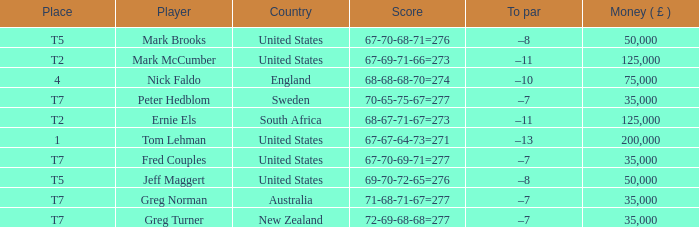What is Score, when Country is "United States", and when Player is "Mark Brooks"? 67-70-68-71=276. Would you mind parsing the complete table? {'header': ['Place', 'Player', 'Country', 'Score', 'To par', 'Money ( £ )'], 'rows': [['T5', 'Mark Brooks', 'United States', '67-70-68-71=276', '–8', '50,000'], ['T2', 'Mark McCumber', 'United States', '67-69-71-66=273', '–11', '125,000'], ['4', 'Nick Faldo', 'England', '68-68-68-70=274', '–10', '75,000'], ['T7', 'Peter Hedblom', 'Sweden', '70-65-75-67=277', '–7', '35,000'], ['T2', 'Ernie Els', 'South Africa', '68-67-71-67=273', '–11', '125,000'], ['1', 'Tom Lehman', 'United States', '67-67-64-73=271', '–13', '200,000'], ['T7', 'Fred Couples', 'United States', '67-70-69-71=277', '–7', '35,000'], ['T5', 'Jeff Maggert', 'United States', '69-70-72-65=276', '–8', '50,000'], ['T7', 'Greg Norman', 'Australia', '71-68-71-67=277', '–7', '35,000'], ['T7', 'Greg Turner', 'New Zealand', '72-69-68-68=277', '–7', '35,000']]} 